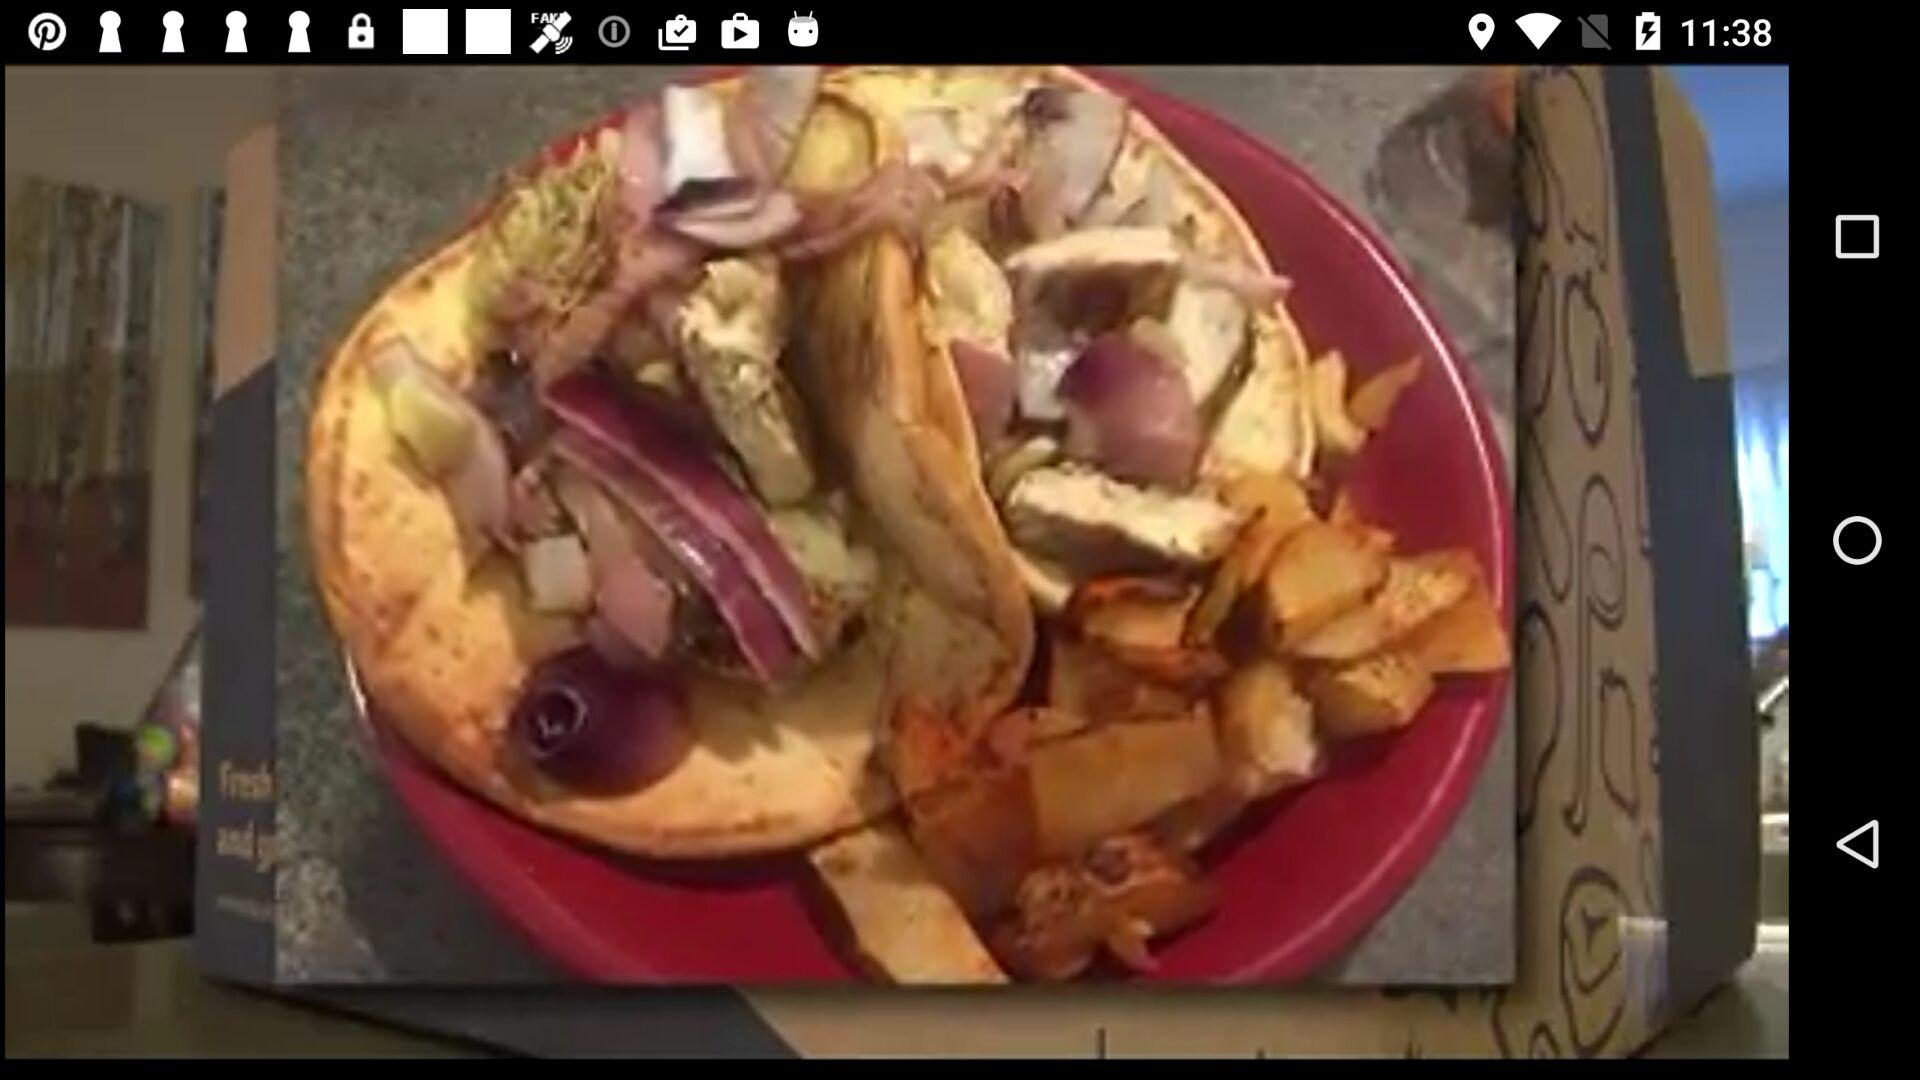What is the selected location? The selected location is Champaign, IL. 